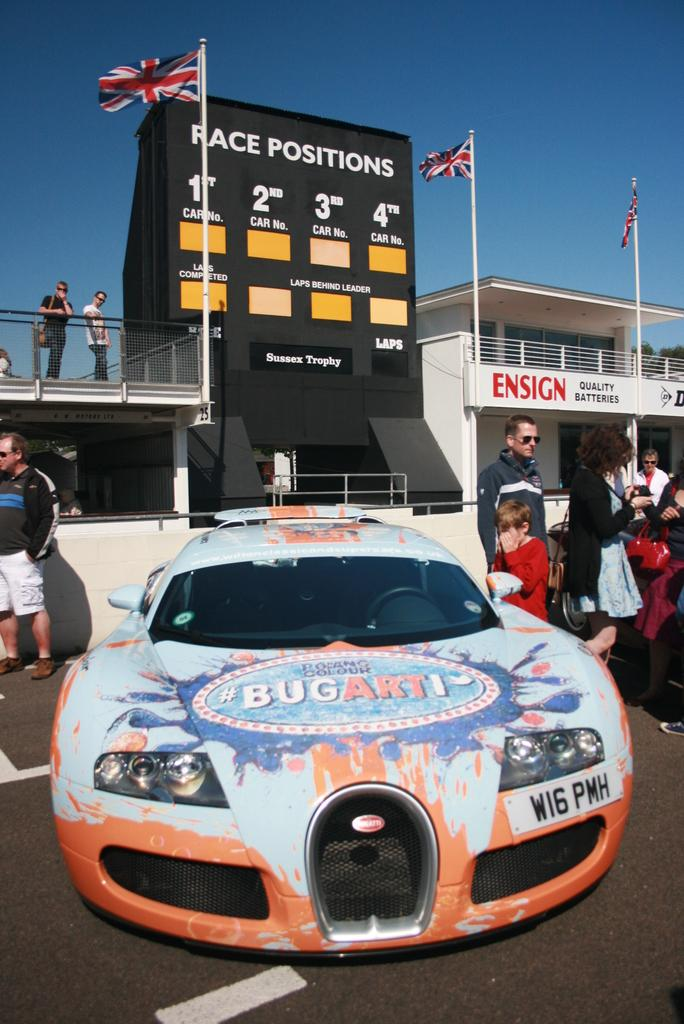How many people can be seen in the image? There are people in the image, but the exact number cannot be determined from the provided facts. What type of vehicle is present in the image? There is a vehicle in the image, but its specific type cannot be determined from the provided facts. What is the purpose of the building in the image? The purpose of the building in the image cannot be determined from the provided facts. What are the poles used for in the image? The purpose of the poles in the image cannot be determined from the provided facts. What does the flag represent in the image? The meaning or representation of the flag in the image cannot be determined from the provided facts. What do the posters with text say in the image? The text on the posters in the image cannot be determined from the provided facts. What sport or event might be taking place based on the presence of the scoreboard in the image? The specific sport or event cannot be determined from the provided facts. What is the purpose of the fencing in the image? The purpose of the fencing in the image cannot be determined from the provided facts. What is the weather like in the image based on the visibility of the sky? The weather cannot be determined from the visibility of the sky alone. How many spoons are visible in the image? There is no mention of spoons in the provided facts, so it cannot be determined if any are present in the image. Can you see the seashore in the image? There is no mention of a seashore in the provided facts, so it cannot be determined if it is visible in the image. How many trucks are present in the image? There is no mention of trucks in the provided facts, so it cannot be determined if any are present in the image. 